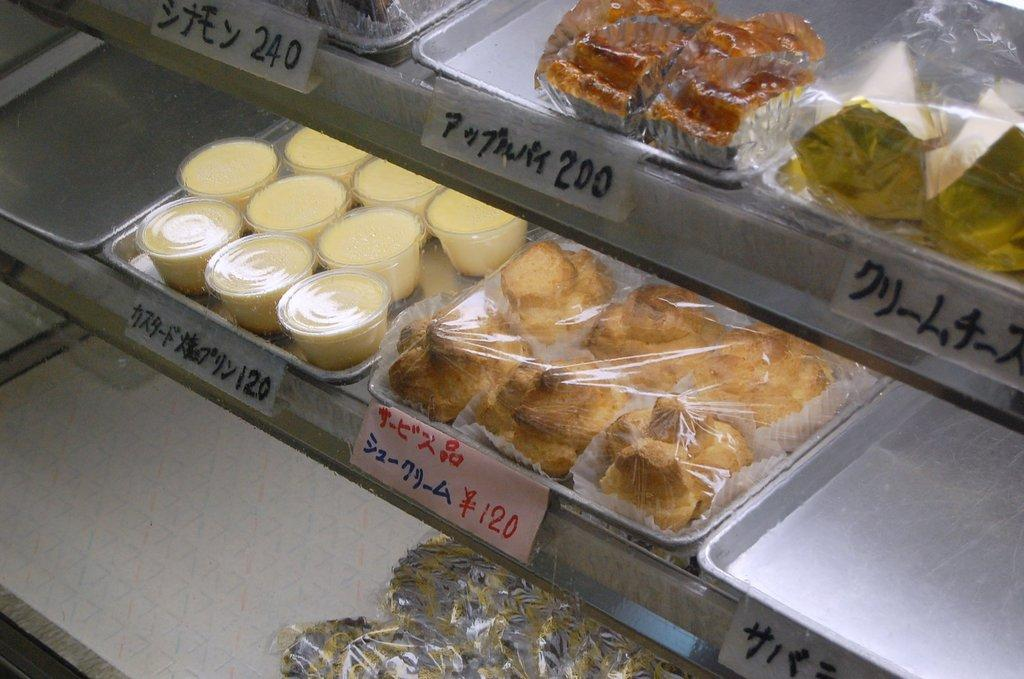What type of storage or display can be seen in the image? There are shelves in the image. What is stored or displayed on the shelves? There are food items in containers in the image. How can the food items be identified or differentiated? There are labels with text in the image. Is there a bear holding a degree in the image? No, there is no bear or degree present in the image. 